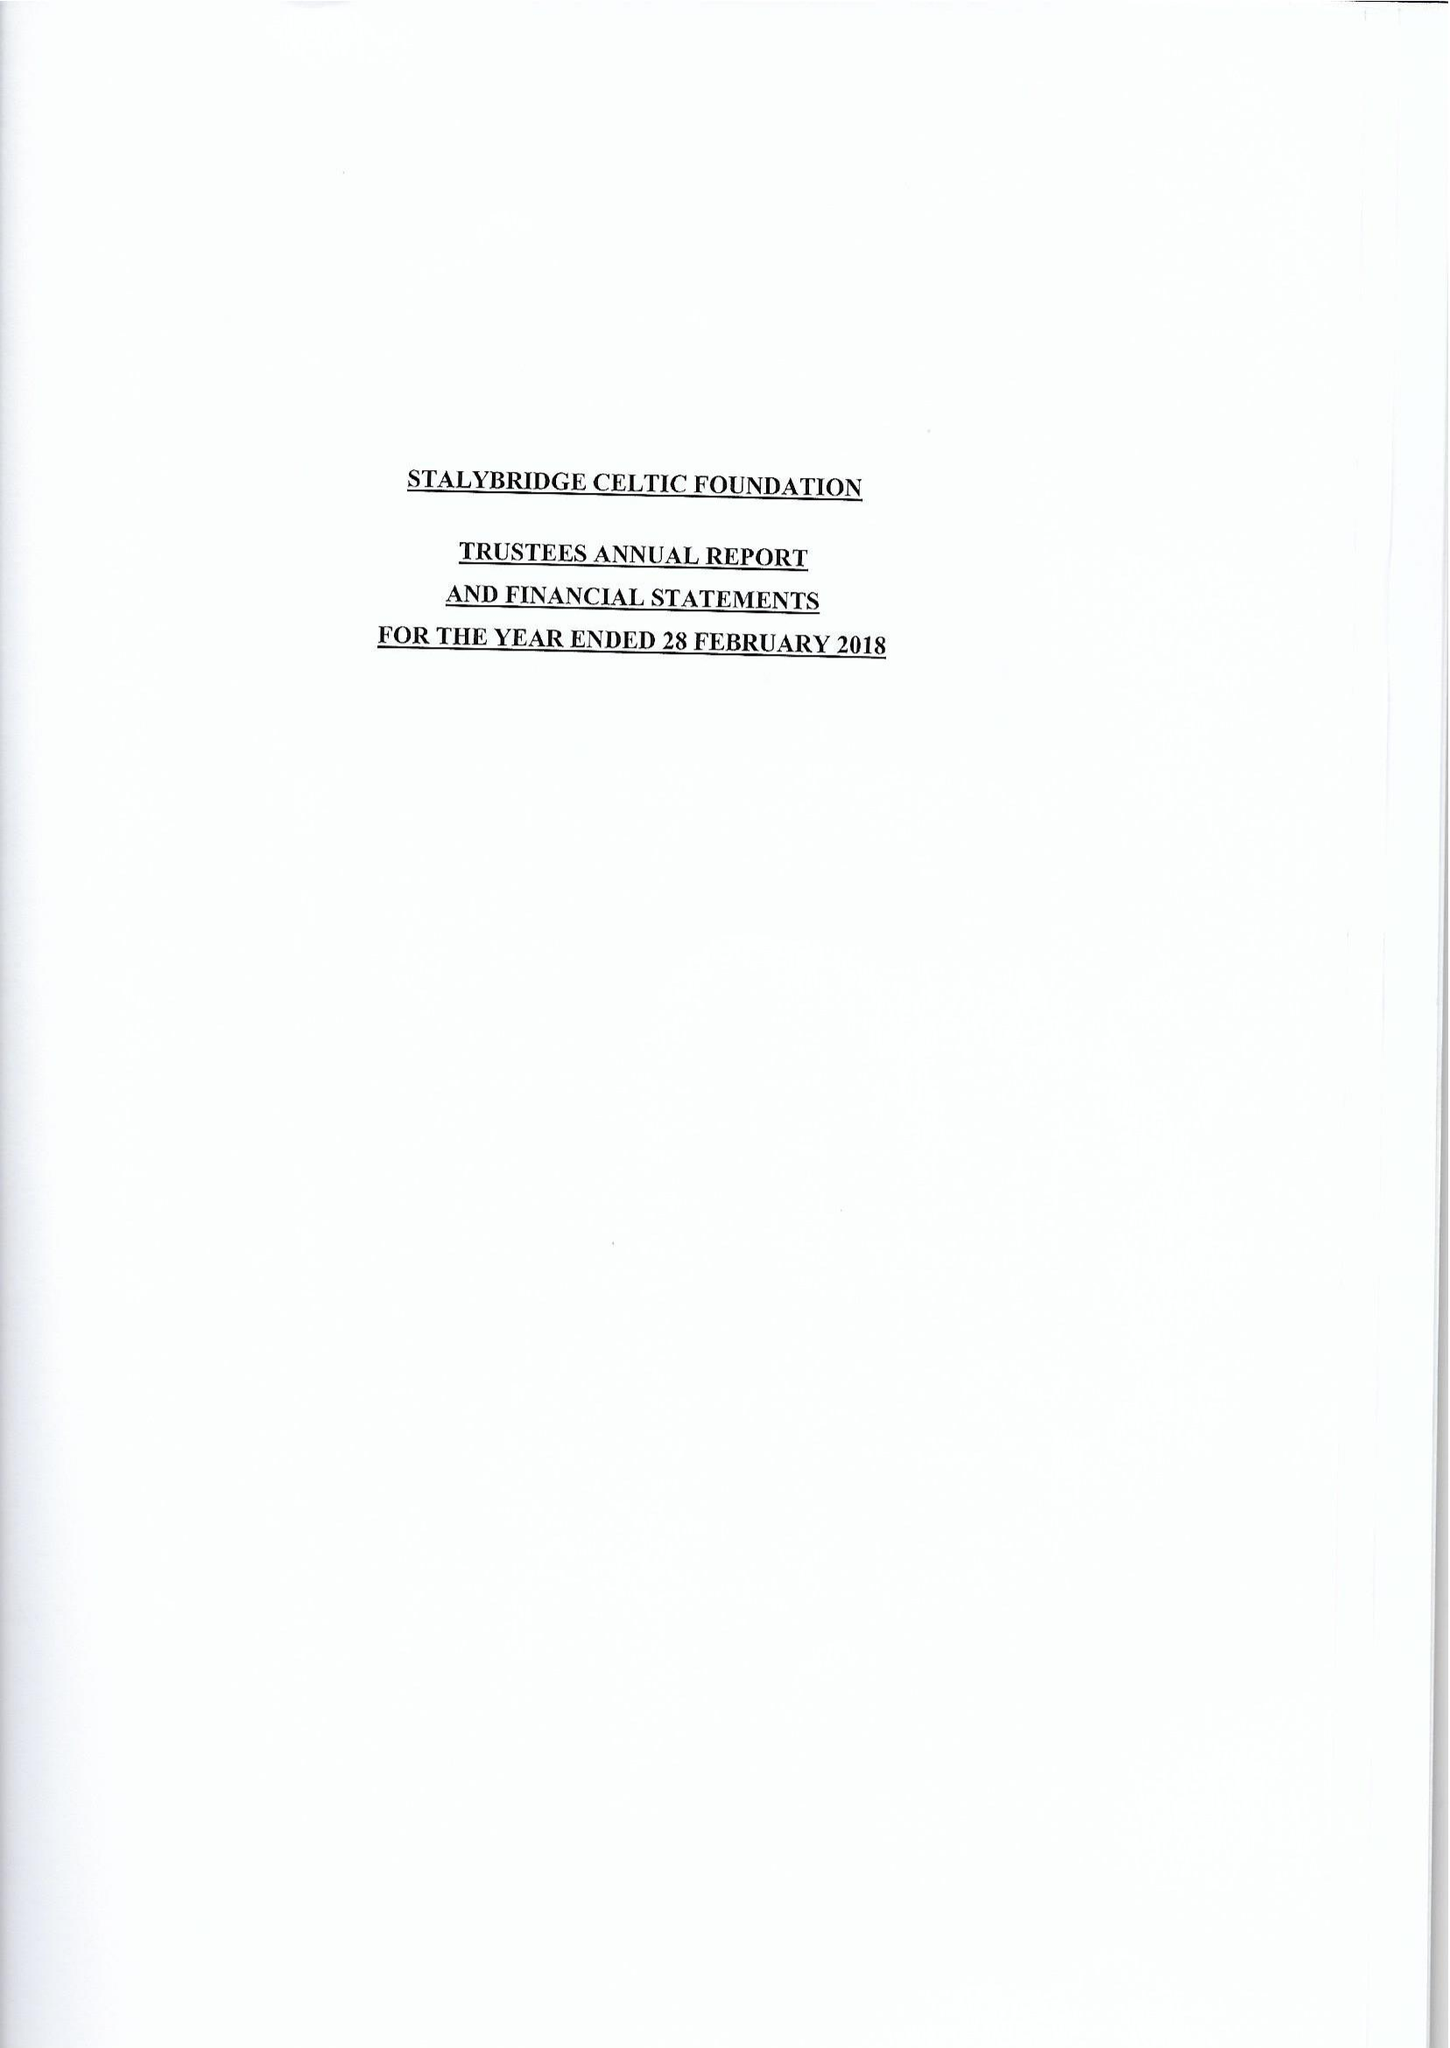What is the value for the charity_name?
Answer the question using a single word or phrase. Stalybridge Celtic Foundation 